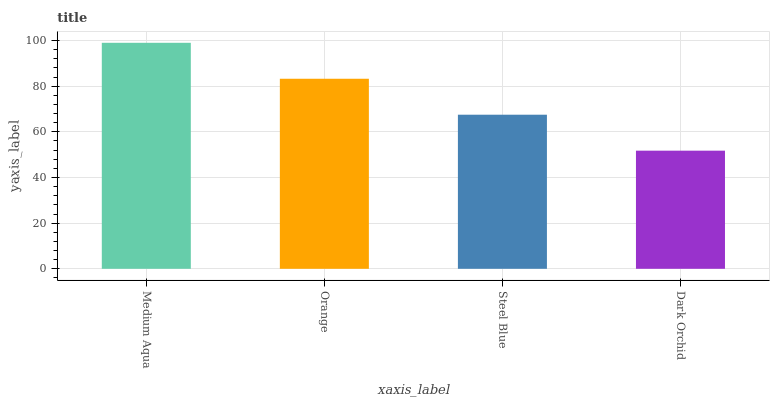Is Dark Orchid the minimum?
Answer yes or no. Yes. Is Medium Aqua the maximum?
Answer yes or no. Yes. Is Orange the minimum?
Answer yes or no. No. Is Orange the maximum?
Answer yes or no. No. Is Medium Aqua greater than Orange?
Answer yes or no. Yes. Is Orange less than Medium Aqua?
Answer yes or no. Yes. Is Orange greater than Medium Aqua?
Answer yes or no. No. Is Medium Aqua less than Orange?
Answer yes or no. No. Is Orange the high median?
Answer yes or no. Yes. Is Steel Blue the low median?
Answer yes or no. Yes. Is Medium Aqua the high median?
Answer yes or no. No. Is Medium Aqua the low median?
Answer yes or no. No. 